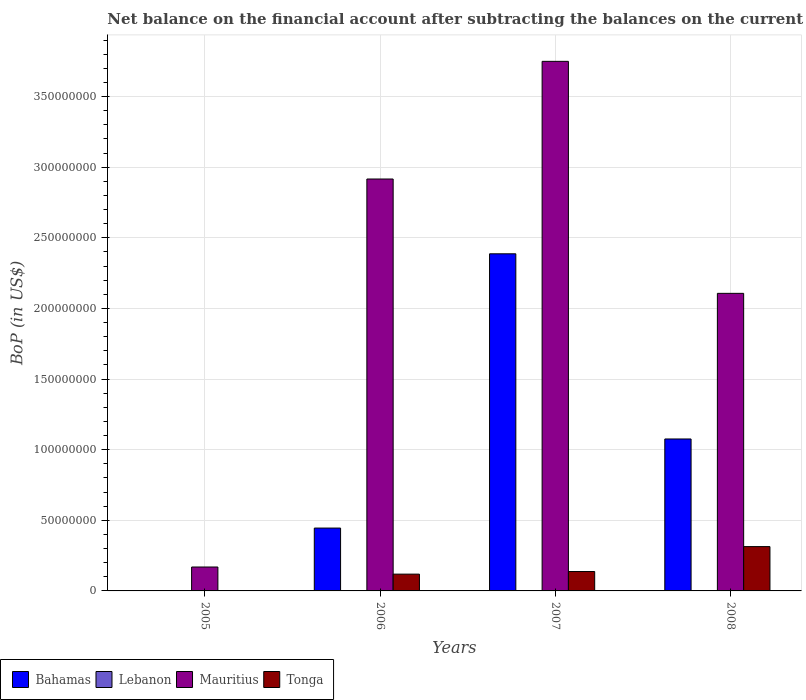How many different coloured bars are there?
Ensure brevity in your answer.  3. Are the number of bars per tick equal to the number of legend labels?
Your answer should be very brief. No. Are the number of bars on each tick of the X-axis equal?
Make the answer very short. No. What is the label of the 2nd group of bars from the left?
Ensure brevity in your answer.  2006. In how many cases, is the number of bars for a given year not equal to the number of legend labels?
Your answer should be compact. 4. What is the Balance of Payments in Bahamas in 2006?
Give a very brief answer. 4.45e+07. Across all years, what is the maximum Balance of Payments in Tonga?
Provide a succinct answer. 3.14e+07. Across all years, what is the minimum Balance of Payments in Tonga?
Provide a succinct answer. 0. What is the total Balance of Payments in Bahamas in the graph?
Your response must be concise. 3.91e+08. What is the difference between the Balance of Payments in Mauritius in 2006 and that in 2007?
Give a very brief answer. -8.33e+07. What is the difference between the Balance of Payments in Bahamas in 2008 and the Balance of Payments in Mauritius in 2005?
Provide a short and direct response. 9.07e+07. What is the average Balance of Payments in Mauritius per year?
Offer a terse response. 2.24e+08. In the year 2008, what is the difference between the Balance of Payments in Bahamas and Balance of Payments in Mauritius?
Give a very brief answer. -1.03e+08. In how many years, is the Balance of Payments in Bahamas greater than 50000000 US$?
Your answer should be very brief. 2. What is the ratio of the Balance of Payments in Bahamas in 2007 to that in 2008?
Ensure brevity in your answer.  2.22. Is the difference between the Balance of Payments in Bahamas in 2007 and 2008 greater than the difference between the Balance of Payments in Mauritius in 2007 and 2008?
Your response must be concise. No. What is the difference between the highest and the second highest Balance of Payments in Mauritius?
Keep it short and to the point. 8.33e+07. What is the difference between the highest and the lowest Balance of Payments in Tonga?
Your response must be concise. 3.14e+07. In how many years, is the Balance of Payments in Bahamas greater than the average Balance of Payments in Bahamas taken over all years?
Offer a very short reply. 2. What is the difference between two consecutive major ticks on the Y-axis?
Give a very brief answer. 5.00e+07. Are the values on the major ticks of Y-axis written in scientific E-notation?
Give a very brief answer. No. Does the graph contain any zero values?
Provide a succinct answer. Yes. Where does the legend appear in the graph?
Keep it short and to the point. Bottom left. How many legend labels are there?
Your answer should be compact. 4. What is the title of the graph?
Your answer should be very brief. Net balance on the financial account after subtracting the balances on the current accounts. What is the label or title of the Y-axis?
Ensure brevity in your answer.  BoP (in US$). What is the BoP (in US$) in Bahamas in 2005?
Provide a succinct answer. 0. What is the BoP (in US$) of Mauritius in 2005?
Your answer should be compact. 1.69e+07. What is the BoP (in US$) of Tonga in 2005?
Offer a terse response. 0. What is the BoP (in US$) in Bahamas in 2006?
Provide a succinct answer. 4.45e+07. What is the BoP (in US$) in Lebanon in 2006?
Keep it short and to the point. 0. What is the BoP (in US$) in Mauritius in 2006?
Keep it short and to the point. 2.92e+08. What is the BoP (in US$) in Tonga in 2006?
Your answer should be very brief. 1.19e+07. What is the BoP (in US$) in Bahamas in 2007?
Your answer should be compact. 2.39e+08. What is the BoP (in US$) of Lebanon in 2007?
Offer a terse response. 0. What is the BoP (in US$) of Mauritius in 2007?
Give a very brief answer. 3.75e+08. What is the BoP (in US$) of Tonga in 2007?
Your answer should be compact. 1.37e+07. What is the BoP (in US$) in Bahamas in 2008?
Ensure brevity in your answer.  1.08e+08. What is the BoP (in US$) of Lebanon in 2008?
Provide a succinct answer. 0. What is the BoP (in US$) in Mauritius in 2008?
Provide a succinct answer. 2.11e+08. What is the BoP (in US$) in Tonga in 2008?
Your answer should be very brief. 3.14e+07. Across all years, what is the maximum BoP (in US$) of Bahamas?
Offer a terse response. 2.39e+08. Across all years, what is the maximum BoP (in US$) in Mauritius?
Provide a succinct answer. 3.75e+08. Across all years, what is the maximum BoP (in US$) in Tonga?
Offer a very short reply. 3.14e+07. Across all years, what is the minimum BoP (in US$) in Bahamas?
Make the answer very short. 0. Across all years, what is the minimum BoP (in US$) of Mauritius?
Your answer should be very brief. 1.69e+07. Across all years, what is the minimum BoP (in US$) in Tonga?
Provide a succinct answer. 0. What is the total BoP (in US$) in Bahamas in the graph?
Ensure brevity in your answer.  3.91e+08. What is the total BoP (in US$) in Lebanon in the graph?
Offer a very short reply. 0. What is the total BoP (in US$) in Mauritius in the graph?
Keep it short and to the point. 8.94e+08. What is the total BoP (in US$) of Tonga in the graph?
Your answer should be compact. 5.70e+07. What is the difference between the BoP (in US$) of Mauritius in 2005 and that in 2006?
Give a very brief answer. -2.75e+08. What is the difference between the BoP (in US$) in Mauritius in 2005 and that in 2007?
Give a very brief answer. -3.58e+08. What is the difference between the BoP (in US$) in Mauritius in 2005 and that in 2008?
Provide a short and direct response. -1.94e+08. What is the difference between the BoP (in US$) in Bahamas in 2006 and that in 2007?
Your response must be concise. -1.94e+08. What is the difference between the BoP (in US$) in Mauritius in 2006 and that in 2007?
Keep it short and to the point. -8.33e+07. What is the difference between the BoP (in US$) of Tonga in 2006 and that in 2007?
Provide a succinct answer. -1.85e+06. What is the difference between the BoP (in US$) in Bahamas in 2006 and that in 2008?
Give a very brief answer. -6.31e+07. What is the difference between the BoP (in US$) of Mauritius in 2006 and that in 2008?
Provide a short and direct response. 8.10e+07. What is the difference between the BoP (in US$) in Tonga in 2006 and that in 2008?
Offer a very short reply. -1.95e+07. What is the difference between the BoP (in US$) in Bahamas in 2007 and that in 2008?
Offer a very short reply. 1.31e+08. What is the difference between the BoP (in US$) in Mauritius in 2007 and that in 2008?
Your response must be concise. 1.64e+08. What is the difference between the BoP (in US$) of Tonga in 2007 and that in 2008?
Your answer should be very brief. -1.77e+07. What is the difference between the BoP (in US$) of Mauritius in 2005 and the BoP (in US$) of Tonga in 2006?
Ensure brevity in your answer.  5.04e+06. What is the difference between the BoP (in US$) of Mauritius in 2005 and the BoP (in US$) of Tonga in 2007?
Make the answer very short. 3.19e+06. What is the difference between the BoP (in US$) of Mauritius in 2005 and the BoP (in US$) of Tonga in 2008?
Ensure brevity in your answer.  -1.45e+07. What is the difference between the BoP (in US$) in Bahamas in 2006 and the BoP (in US$) in Mauritius in 2007?
Offer a terse response. -3.30e+08. What is the difference between the BoP (in US$) of Bahamas in 2006 and the BoP (in US$) of Tonga in 2007?
Provide a succinct answer. 3.08e+07. What is the difference between the BoP (in US$) in Mauritius in 2006 and the BoP (in US$) in Tonga in 2007?
Offer a very short reply. 2.78e+08. What is the difference between the BoP (in US$) in Bahamas in 2006 and the BoP (in US$) in Mauritius in 2008?
Ensure brevity in your answer.  -1.66e+08. What is the difference between the BoP (in US$) in Bahamas in 2006 and the BoP (in US$) in Tonga in 2008?
Give a very brief answer. 1.31e+07. What is the difference between the BoP (in US$) of Mauritius in 2006 and the BoP (in US$) of Tonga in 2008?
Provide a succinct answer. 2.60e+08. What is the difference between the BoP (in US$) in Bahamas in 2007 and the BoP (in US$) in Mauritius in 2008?
Your answer should be very brief. 2.80e+07. What is the difference between the BoP (in US$) of Bahamas in 2007 and the BoP (in US$) of Tonga in 2008?
Ensure brevity in your answer.  2.07e+08. What is the difference between the BoP (in US$) in Mauritius in 2007 and the BoP (in US$) in Tonga in 2008?
Ensure brevity in your answer.  3.44e+08. What is the average BoP (in US$) of Bahamas per year?
Provide a short and direct response. 9.77e+07. What is the average BoP (in US$) in Mauritius per year?
Your response must be concise. 2.24e+08. What is the average BoP (in US$) in Tonga per year?
Keep it short and to the point. 1.42e+07. In the year 2006, what is the difference between the BoP (in US$) in Bahamas and BoP (in US$) in Mauritius?
Offer a terse response. -2.47e+08. In the year 2006, what is the difference between the BoP (in US$) of Bahamas and BoP (in US$) of Tonga?
Offer a terse response. 3.26e+07. In the year 2006, what is the difference between the BoP (in US$) of Mauritius and BoP (in US$) of Tonga?
Provide a short and direct response. 2.80e+08. In the year 2007, what is the difference between the BoP (in US$) of Bahamas and BoP (in US$) of Mauritius?
Offer a terse response. -1.36e+08. In the year 2007, what is the difference between the BoP (in US$) of Bahamas and BoP (in US$) of Tonga?
Your response must be concise. 2.25e+08. In the year 2007, what is the difference between the BoP (in US$) of Mauritius and BoP (in US$) of Tonga?
Your response must be concise. 3.61e+08. In the year 2008, what is the difference between the BoP (in US$) of Bahamas and BoP (in US$) of Mauritius?
Keep it short and to the point. -1.03e+08. In the year 2008, what is the difference between the BoP (in US$) of Bahamas and BoP (in US$) of Tonga?
Make the answer very short. 7.62e+07. In the year 2008, what is the difference between the BoP (in US$) in Mauritius and BoP (in US$) in Tonga?
Offer a very short reply. 1.79e+08. What is the ratio of the BoP (in US$) of Mauritius in 2005 to that in 2006?
Keep it short and to the point. 0.06. What is the ratio of the BoP (in US$) of Mauritius in 2005 to that in 2007?
Provide a short and direct response. 0.05. What is the ratio of the BoP (in US$) in Mauritius in 2005 to that in 2008?
Offer a terse response. 0.08. What is the ratio of the BoP (in US$) of Bahamas in 2006 to that in 2007?
Your answer should be very brief. 0.19. What is the ratio of the BoP (in US$) of Tonga in 2006 to that in 2007?
Provide a short and direct response. 0.87. What is the ratio of the BoP (in US$) of Bahamas in 2006 to that in 2008?
Keep it short and to the point. 0.41. What is the ratio of the BoP (in US$) in Mauritius in 2006 to that in 2008?
Your answer should be very brief. 1.38. What is the ratio of the BoP (in US$) in Tonga in 2006 to that in 2008?
Give a very brief answer. 0.38. What is the ratio of the BoP (in US$) in Bahamas in 2007 to that in 2008?
Offer a terse response. 2.22. What is the ratio of the BoP (in US$) in Mauritius in 2007 to that in 2008?
Your answer should be very brief. 1.78. What is the ratio of the BoP (in US$) of Tonga in 2007 to that in 2008?
Your answer should be compact. 0.44. What is the difference between the highest and the second highest BoP (in US$) in Bahamas?
Offer a terse response. 1.31e+08. What is the difference between the highest and the second highest BoP (in US$) of Mauritius?
Offer a very short reply. 8.33e+07. What is the difference between the highest and the second highest BoP (in US$) in Tonga?
Provide a short and direct response. 1.77e+07. What is the difference between the highest and the lowest BoP (in US$) of Bahamas?
Your answer should be very brief. 2.39e+08. What is the difference between the highest and the lowest BoP (in US$) of Mauritius?
Offer a terse response. 3.58e+08. What is the difference between the highest and the lowest BoP (in US$) of Tonga?
Your answer should be very brief. 3.14e+07. 